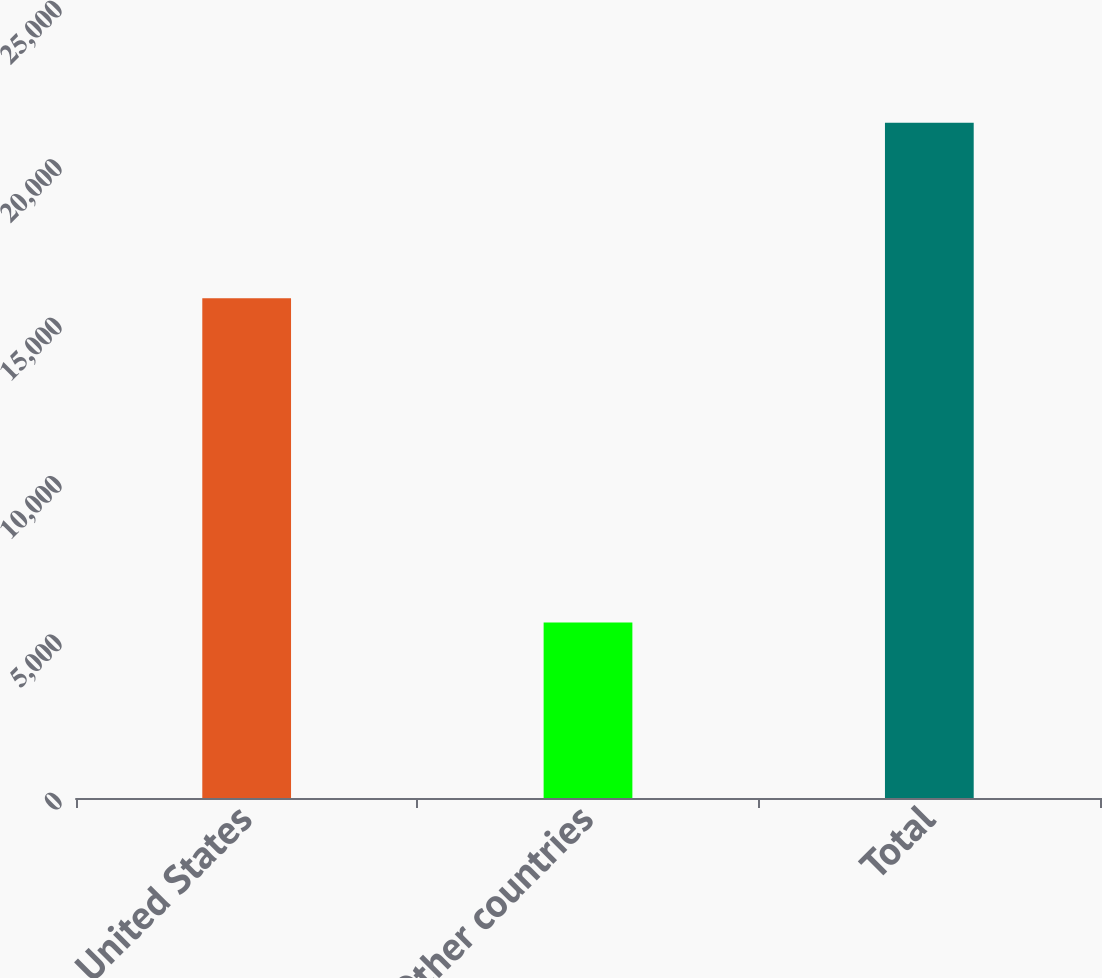Convert chart to OTSL. <chart><loc_0><loc_0><loc_500><loc_500><bar_chart><fcel>United States<fcel>Other countries<fcel>Total<nl><fcel>15774.8<fcel>5541.1<fcel>21315.9<nl></chart> 